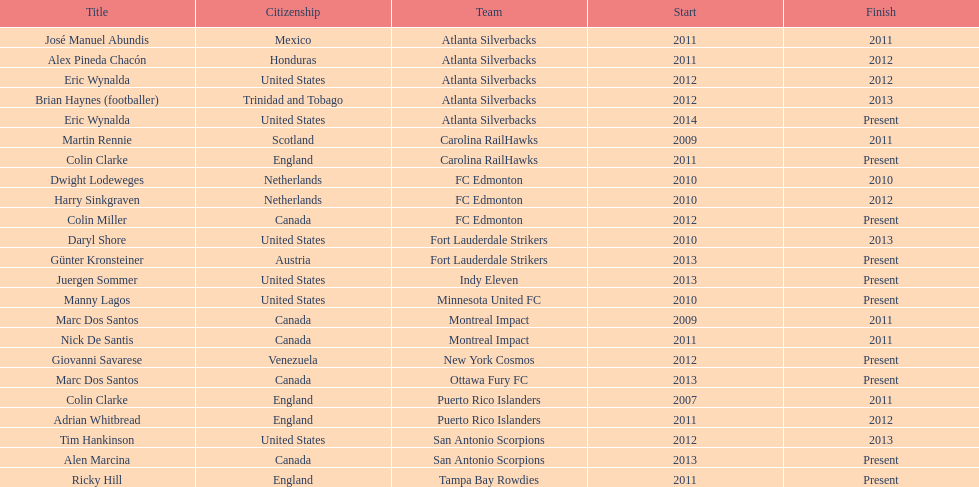What year did marc dos santos start as coach? 2009. Besides marc dos santos, what other coach started in 2009? Martin Rennie. 